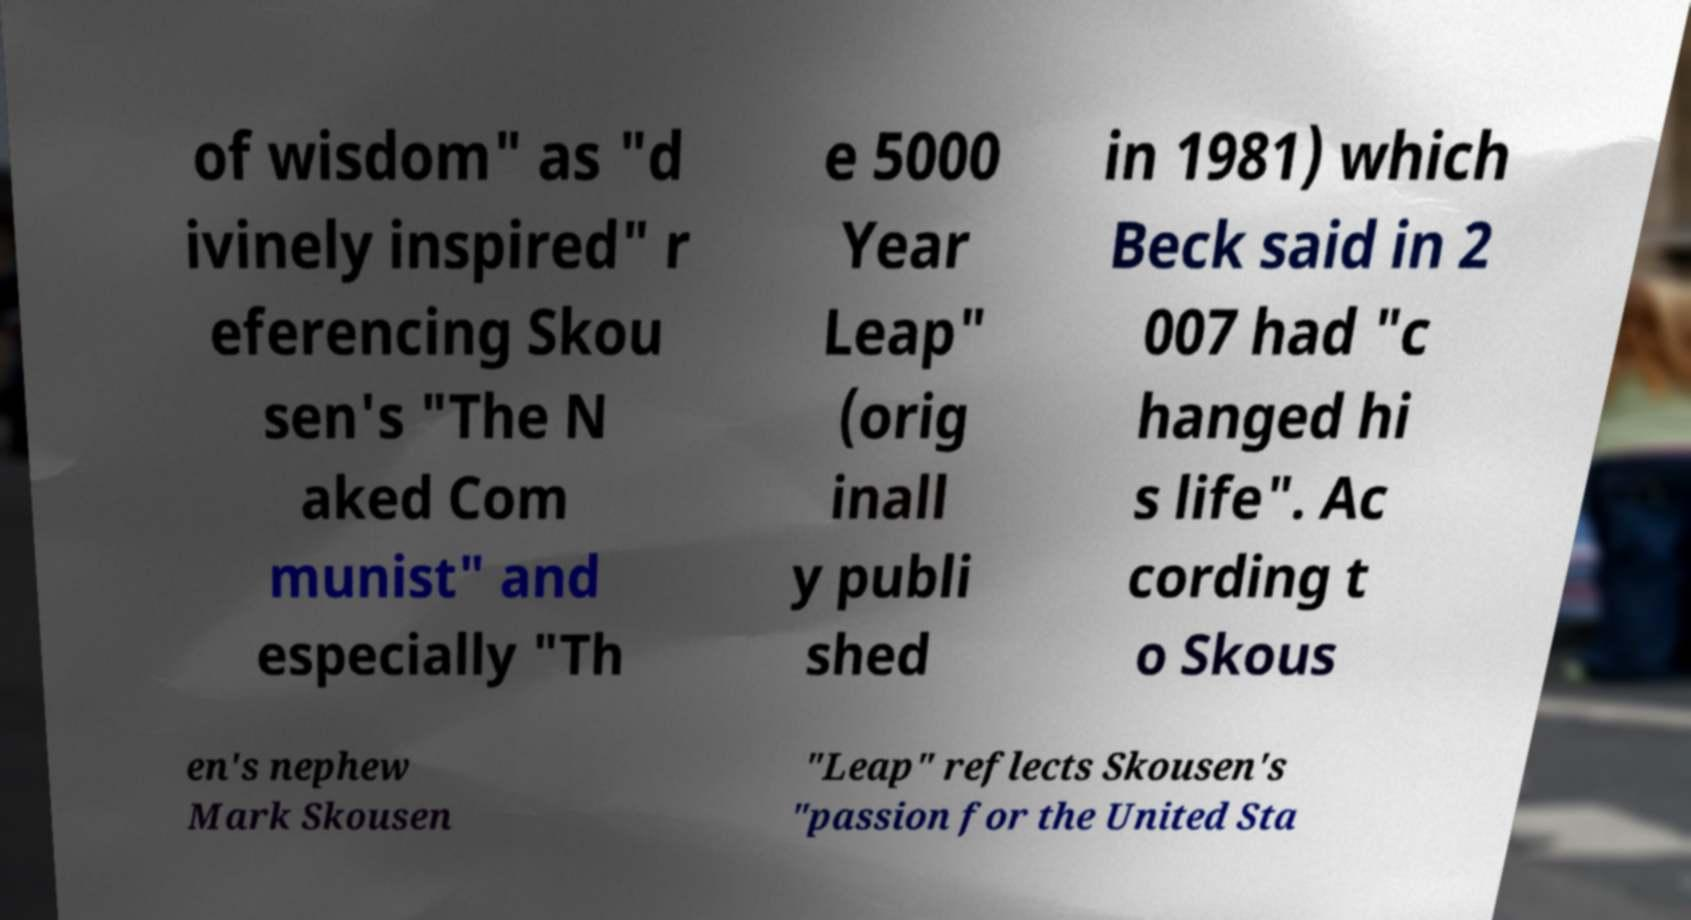There's text embedded in this image that I need extracted. Can you transcribe it verbatim? of wisdom" as "d ivinely inspired" r eferencing Skou sen's "The N aked Com munist" and especially "Th e 5000 Year Leap" (orig inall y publi shed in 1981) which Beck said in 2 007 had "c hanged hi s life". Ac cording t o Skous en's nephew Mark Skousen "Leap" reflects Skousen's "passion for the United Sta 